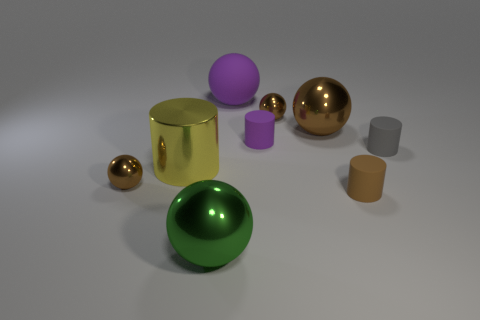Subtract all gray blocks. How many brown balls are left? 3 Subtract all purple balls. How many balls are left? 4 Subtract all gray spheres. Subtract all purple cubes. How many spheres are left? 5 Subtract all cylinders. How many objects are left? 5 Subtract all green things. Subtract all large matte objects. How many objects are left? 7 Add 2 large yellow metallic objects. How many large yellow metallic objects are left? 3 Add 5 big red matte objects. How many big red matte objects exist? 5 Subtract 1 purple cylinders. How many objects are left? 8 